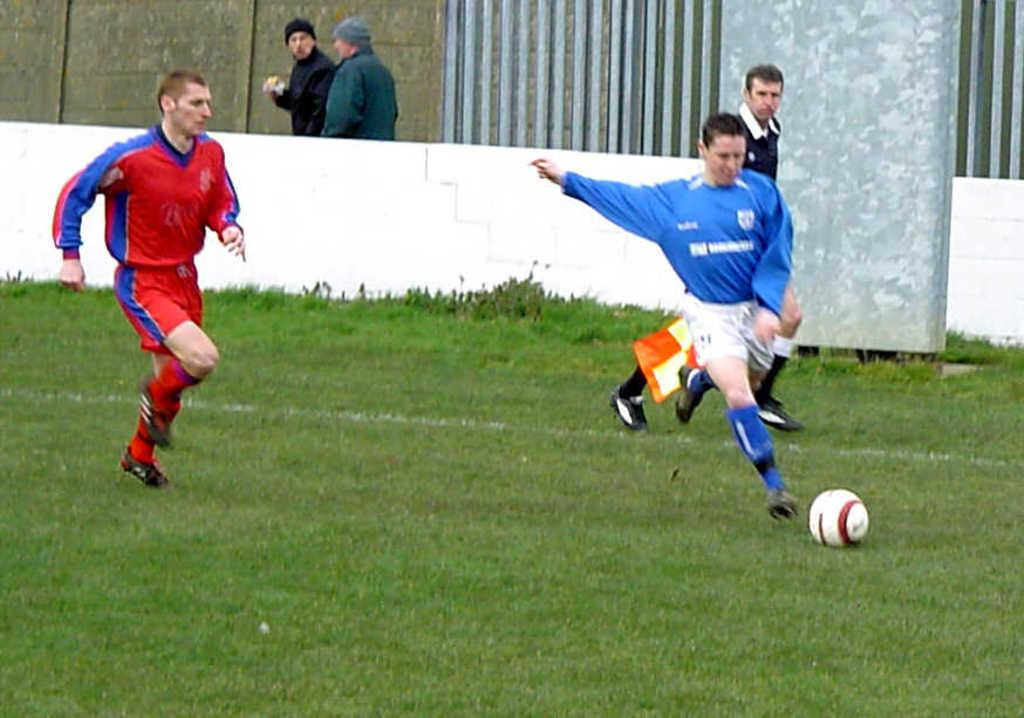What sport are the players engaged in on the field? The players are playing soccer in the field. What are the people in the background doing? The people in the background are walking. What is the color of the grass in the field? The grass in the field appears green. What type of wrist accessory is being worn by the soccer players? There is no mention of any wrist accessory being worn by the soccer players in the image. What kind of soup is being served to the people walking in the background? There is no soup present in the image; the people walking in the background are not engaged in any activity related to food or drink. 